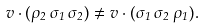Convert formula to latex. <formula><loc_0><loc_0><loc_500><loc_500>v \cdot ( \rho _ { 2 } \, \sigma _ { 1 } \, \sigma _ { 2 } ) \neq v \cdot ( \sigma _ { 1 } \, \sigma _ { 2 } \, \rho _ { 1 } ) .</formula> 